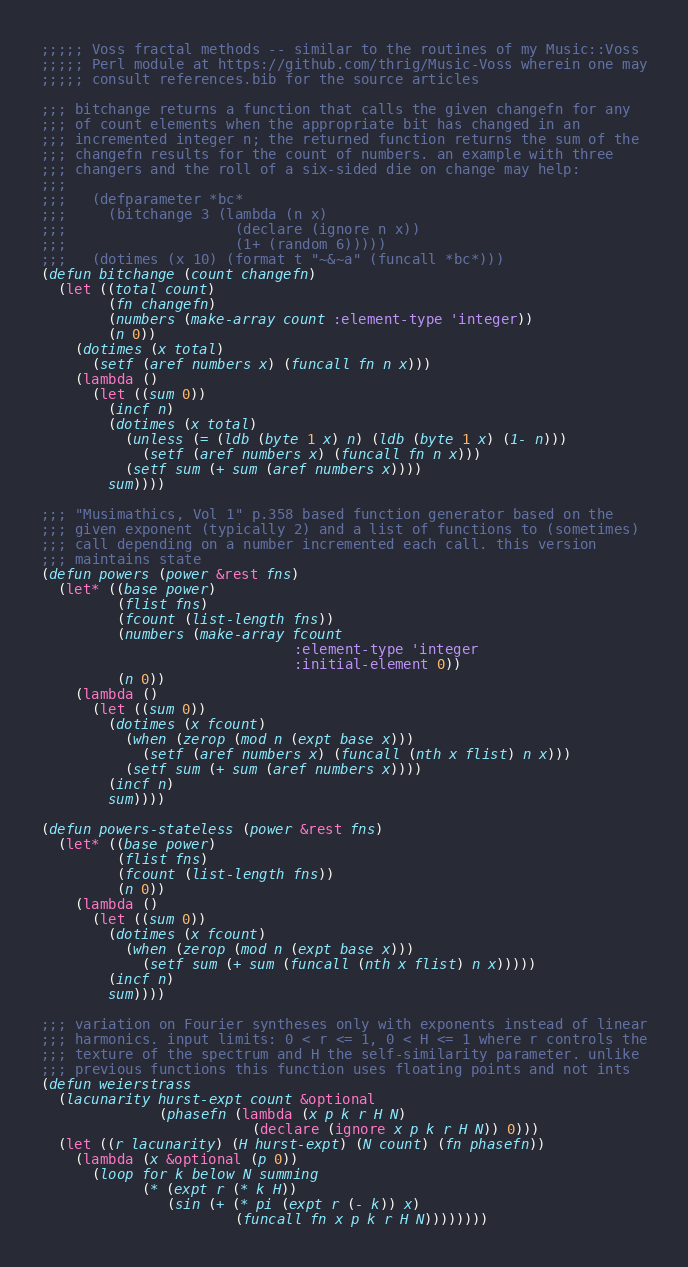<code> <loc_0><loc_0><loc_500><loc_500><_Lisp_>;;;;; Voss fractal methods -- similar to the routines of my Music::Voss
;;;;; Perl module at https://github.com/thrig/Music-Voss wherein one may
;;;;; consult references.bib for the source articles

;;; bitchange returns a function that calls the given changefn for any
;;; of count elements when the appropriate bit has changed in an
;;; incremented integer n; the returned function returns the sum of the
;;; changefn results for the count of numbers. an example with three
;;; changers and the roll of a six-sided die on change may help:
;;;
;;;   (defparameter *bc*
;;;     (bitchange 3 (lambda (n x)
;;;                    (declare (ignore n x))
;;;                    (1+ (random 6)))))
;;;   (dotimes (x 10) (format t "~&~a" (funcall *bc*)))
(defun bitchange (count changefn)
  (let ((total count)
        (fn changefn)
        (numbers (make-array count :element-type 'integer))
        (n 0))
    (dotimes (x total)
      (setf (aref numbers x) (funcall fn n x)))
    (lambda ()
      (let ((sum 0))
        (incf n)
        (dotimes (x total)
          (unless (= (ldb (byte 1 x) n) (ldb (byte 1 x) (1- n)))
            (setf (aref numbers x) (funcall fn n x)))
          (setf sum (+ sum (aref numbers x))))
        sum))))

;;; "Musimathics, Vol 1" p.358 based function generator based on the
;;; given exponent (typically 2) and a list of functions to (sometimes)
;;; call depending on a number incremented each call. this version
;;; maintains state
(defun powers (power &rest fns)
  (let* ((base power)
         (flist fns)
         (fcount (list-length fns))
         (numbers (make-array fcount
                              :element-type 'integer
                              :initial-element 0))
         (n 0))
    (lambda ()
      (let ((sum 0))
        (dotimes (x fcount)
          (when (zerop (mod n (expt base x)))
            (setf (aref numbers x) (funcall (nth x flist) n x)))
          (setf sum (+ sum (aref numbers x))))
        (incf n)
        sum))))

(defun powers-stateless (power &rest fns)
  (let* ((base power)
         (flist fns)
         (fcount (list-length fns))
         (n 0))
    (lambda ()
      (let ((sum 0))
        (dotimes (x fcount)
          (when (zerop (mod n (expt base x)))
            (setf sum (+ sum (funcall (nth x flist) n x)))))
        (incf n)
        sum))))

;;; variation on Fourier syntheses only with exponents instead of linear
;;; harmonics. input limits: 0 < r <= 1, 0 < H <= 1 where r controls the
;;; texture of the spectrum and H the self-similarity parameter. unlike
;;; previous functions this function uses floating points and not ints
(defun weierstrass
  (lacunarity hurst-expt count &optional
              (phasefn (lambda (x p k r H N)
                         (declare (ignore x p k r H N)) 0)))
  (let ((r lacunarity) (H hurst-expt) (N count) (fn phasefn))
    (lambda (x &optional (p 0))
      (loop for k below N summing
            (* (expt r (* k H))
               (sin (+ (* pi (expt r (- k)) x)
                       (funcall fn x p k r H N))))))))
</code> 